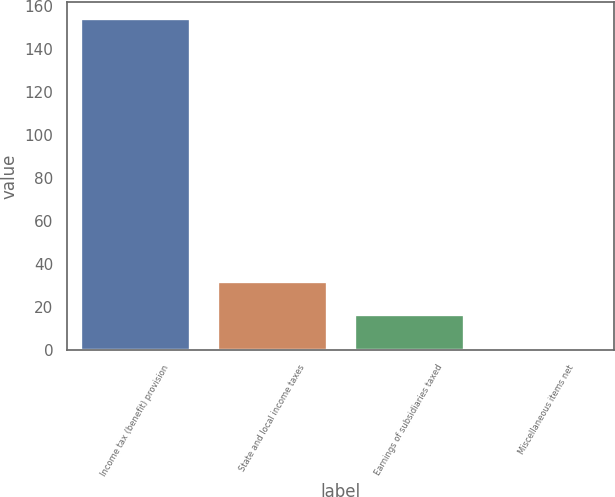<chart> <loc_0><loc_0><loc_500><loc_500><bar_chart><fcel>Income tax (benefit) provision<fcel>State and local income taxes<fcel>Earnings of subsidiaries taxed<fcel>Miscellaneous items net<nl><fcel>154.2<fcel>32.04<fcel>16.77<fcel>1.5<nl></chart> 